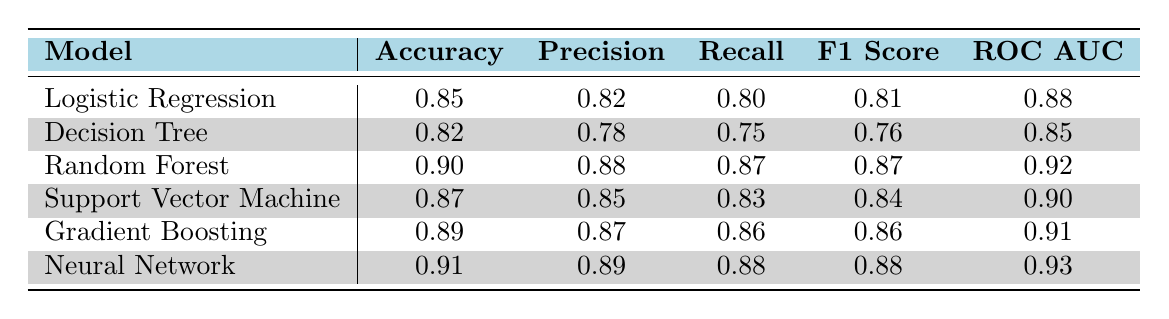What is the accuracy of the Random Forest model? According to the table, the accuracy for the Random Forest model is listed directly. It shows a value of 0.90 under the Accuracy column.
Answer: 0.90 Which model has the highest recall value? By inspecting the Recall column, the Neural Network has the highest recall value of 0.88, which is the maximum among all models listed.
Answer: Neural Network What is the average F1 score of all the models? To calculate the average F1 score, we sum all the F1 scores (0.81 + 0.76 + 0.87 + 0.84 + 0.86 + 0.88 = 5.02) and divide by the number of models (6). Thus, the average F1 score is 5.02 / 6 = 0.8367.
Answer: 0.84 Is the precision of Support Vector Machine greater than the precision of Decision Tree? Looking at the Precision column, the Support Vector Machine has a precision of 0.85 while the Decision Tree has 0.78. Since 0.85 is greater than 0.78, the statement is true.
Answer: Yes What is the difference in ROC AUC between Neural Network and Decision Tree? The ROC AUC value for Neural Network is 0.93 and for Decision Tree is 0.85. The difference can be calculated as 0.93 - 0.85 = 0.08.
Answer: 0.08 Which model has the lowest accuracy? By examining the Accuracy column, the Decision Tree has the lowest accuracy at 0.82 compared to all other models.
Answer: Decision Tree Are the precision and recall of Gradient Boosting model equal? For Gradient Boosting, the precision is 0.87 and the recall is 0.86, so they are not equal. Thus the statement is false.
Answer: No Which model performs best in terms of both Accuracy and ROC AUC? The model with the best performance in terms of both metrics is the Neural Network, which has an accuracy of 0.91 and the highest ROC AUC of 0.93 compared to the others.
Answer: Neural Network 